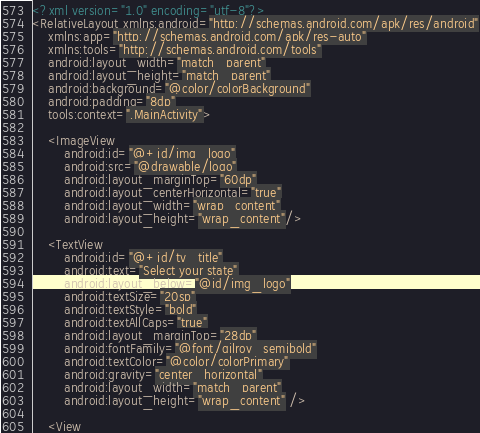Convert code to text. <code><loc_0><loc_0><loc_500><loc_500><_XML_><?xml version="1.0" encoding="utf-8"?>
<RelativeLayout xmlns:android="http://schemas.android.com/apk/res/android"
    xmlns:app="http://schemas.android.com/apk/res-auto"
    xmlns:tools="http://schemas.android.com/tools"
    android:layout_width="match_parent"
    android:layout_height="match_parent"
    android:background="@color/colorBackground"
    android:padding="8dp"
    tools:context=".MainActivity">

    <ImageView
        android:id="@+id/img_logo"
        android:src="@drawable/logo"
        android:layout_marginTop="60dp"
        android:layout_centerHorizontal="true"
        android:layout_width="wrap_content"
        android:layout_height="wrap_content"/>

    <TextView
        android:id="@+id/tv_title"
        android:text="Select your state"
        android:layout_below="@id/img_logo"
        android:textSize="20sp"
        android:textStyle="bold"
        android:textAllCaps="true"
        android:layout_marginTop="28dp"
        android:fontFamily="@font/gilroy_semibold"
        android:textColor="@color/colorPrimary"
        android:gravity="center_horizontal"
        android:layout_width="match_parent"
        android:layout_height="wrap_content" />

    <View</code> 